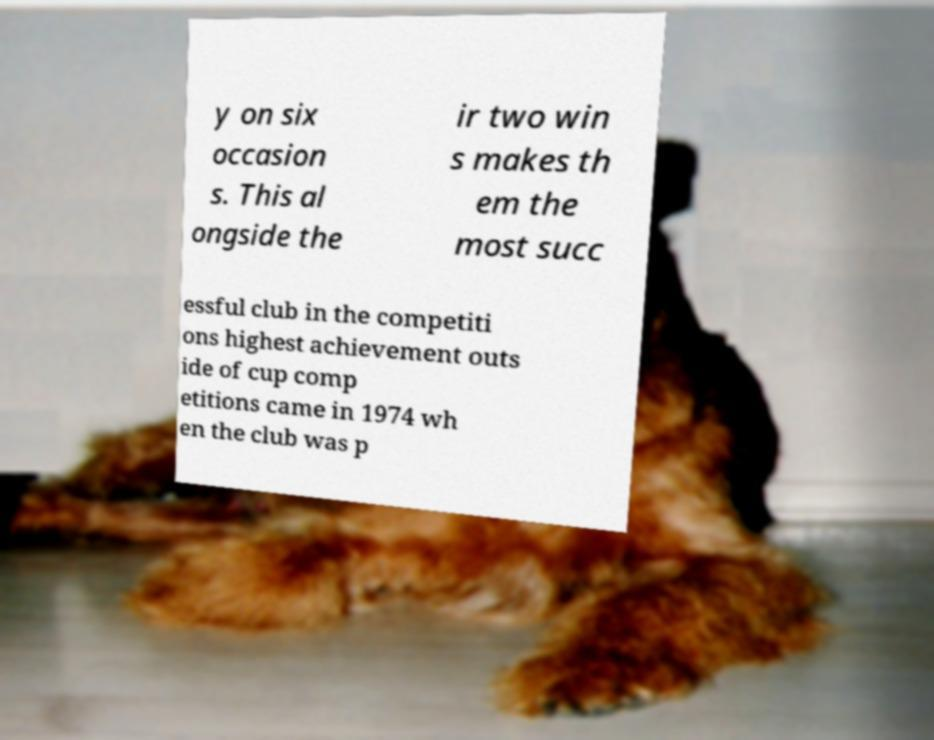I need the written content from this picture converted into text. Can you do that? y on six occasion s. This al ongside the ir two win s makes th em the most succ essful club in the competiti ons highest achievement outs ide of cup comp etitions came in 1974 wh en the club was p 